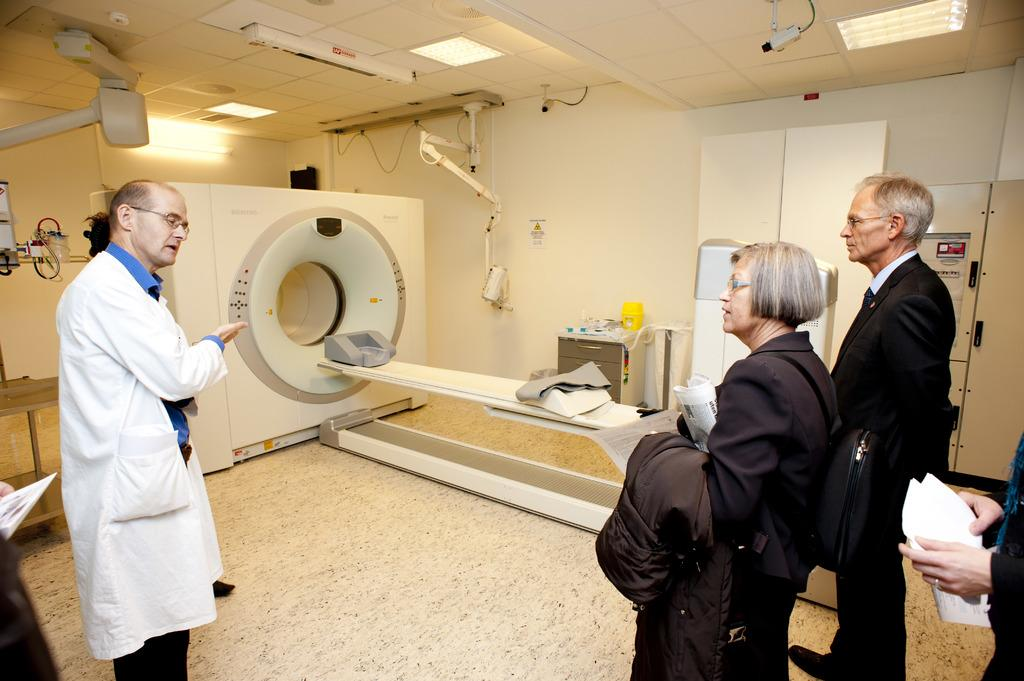What is the profession of the person in the image? There is a doctor in the image. What is the doctor wearing? The doctor is wearing a white uniform. What is the doctor explaining to the other people in the image? The doctor is explaining about a CT scan machine. How many people are in the image besides the doctor? There are two people in the image. What are the two people wearing? The two people are wearing black coats. What are the two people doing in the image? The two people are listening to the doctor. What type of mint plant can be seen growing in a circle in the image? There is no mint plant or circle present in the image. 